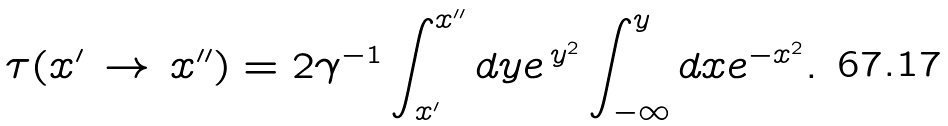<formula> <loc_0><loc_0><loc_500><loc_500>\tau ( x ^ { \prime } \, \to \, x ^ { \prime \prime } ) = 2 \gamma ^ { - 1 } \int _ { x ^ { \prime } } ^ { x ^ { \prime \prime } } d y e ^ { \, y ^ { 2 } } \int _ { - \infty } ^ { y } d x e ^ { - x ^ { 2 } } .</formula> 